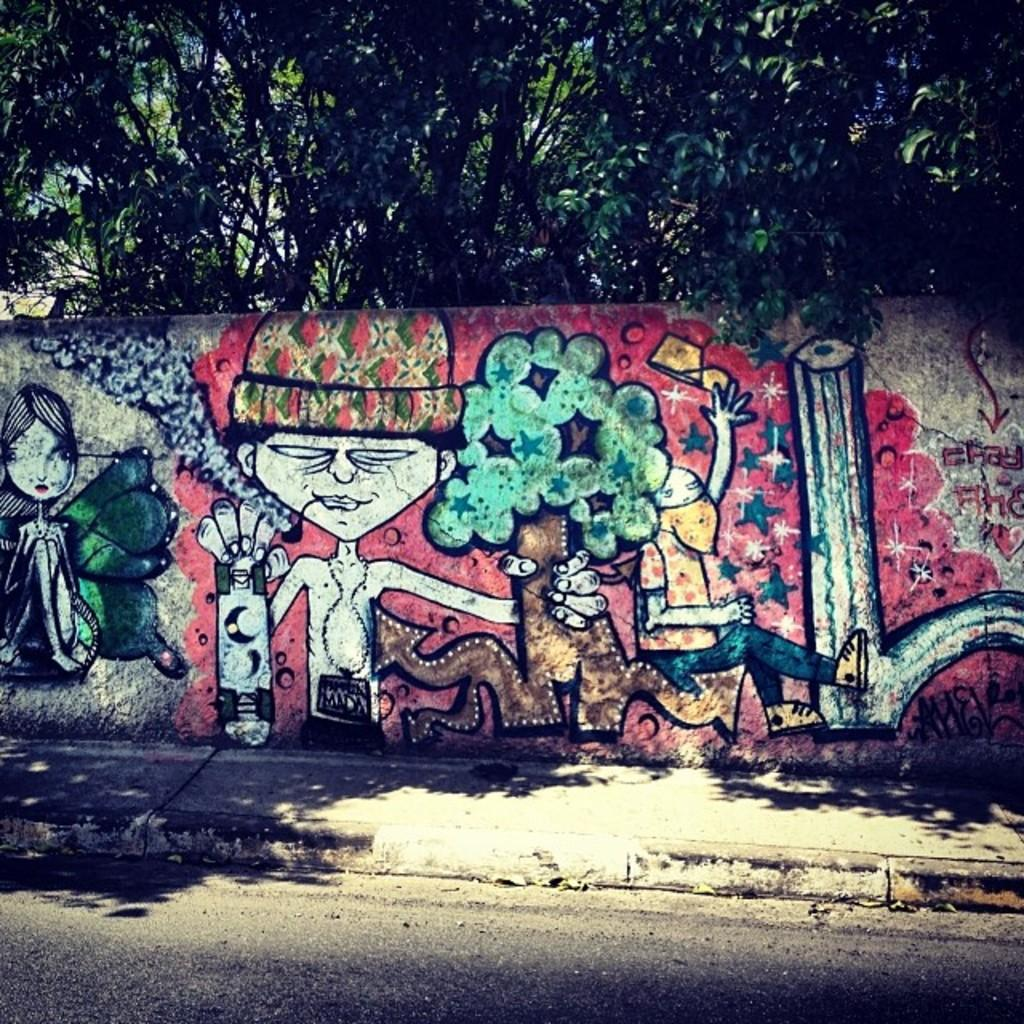What is the main feature of the image? There is a road in the image. What else can be seen in the image besides the road? There is a wall in the image, with paintings of people and trees on it. Are there any trees visible in the background of the image? Yes, there are trees visible in the background of the image. What type of loaf can be seen in the image? There is no loaf present in the image. Can you describe the snail's habitat in the image? There are no snails or any indication of a snail's habitat in the image. 